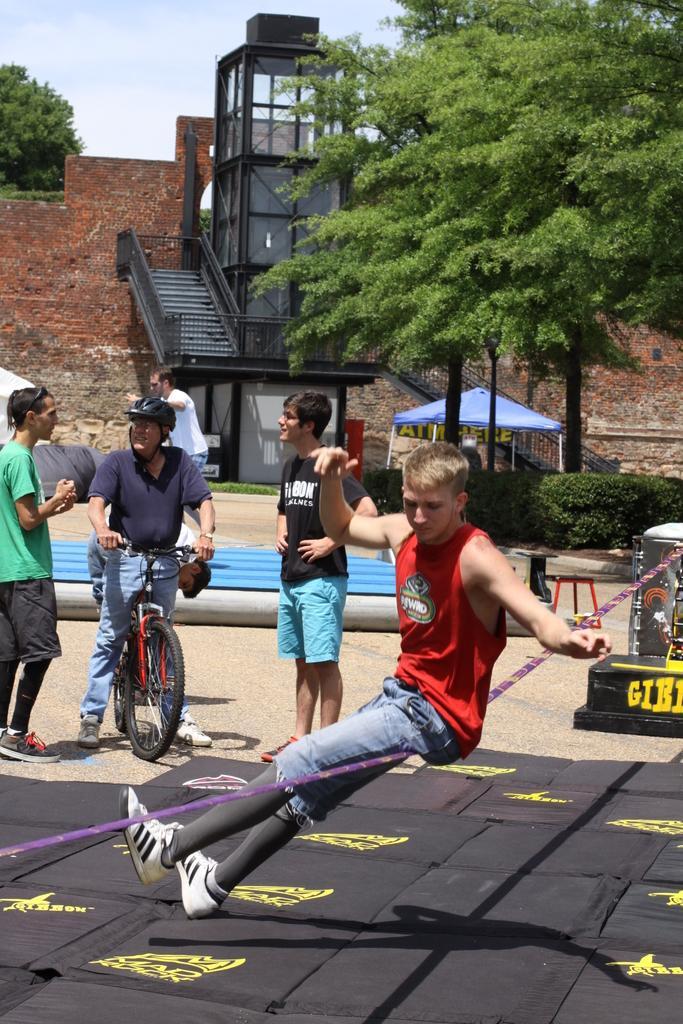Please provide a concise description of this image. This picture shows some men were standing and a middle guy is riding a bicycle and wearing a helmet. There is another guy performing activity with a rope. In the background there are some trees, wall and a sky here. 